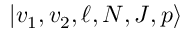Convert formula to latex. <formula><loc_0><loc_0><loc_500><loc_500>| v _ { 1 } , v _ { 2 } , \ell , N , J , p \rangle</formula> 